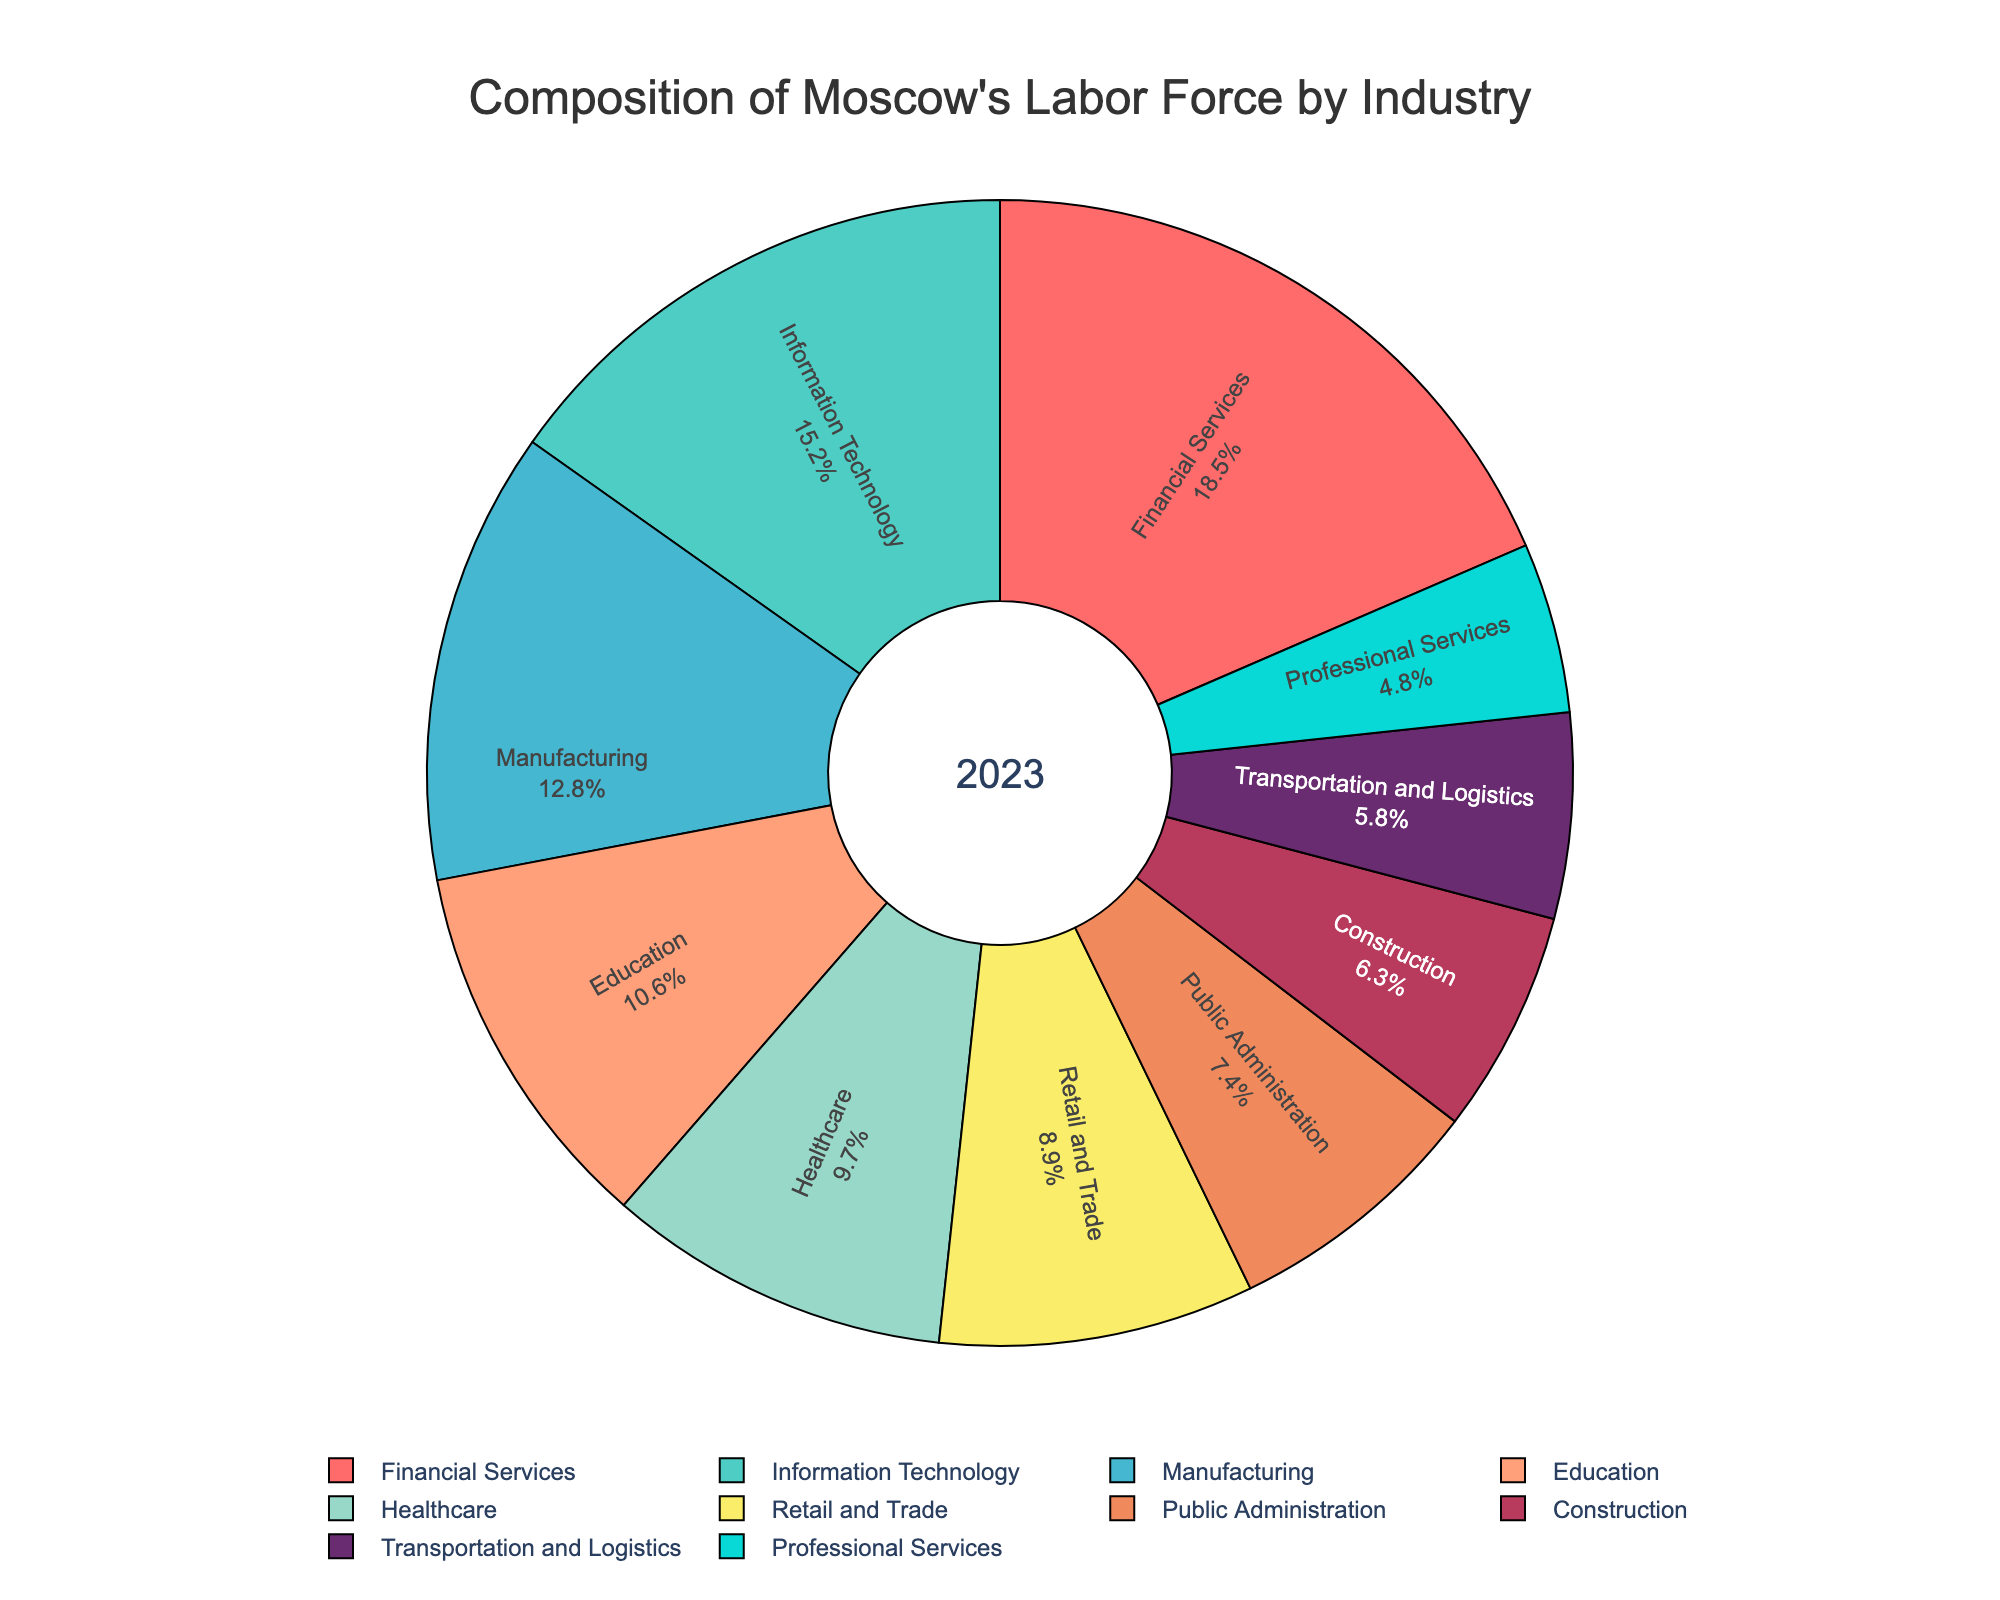Which industry has the largest percentage of Moscow's labor force? By examining the pie chart, Financial Services is the sector with the largest slice, corresponding to 18.5%.
Answer: Financial Services What is the combined percentage of Moscow's labor force in Information Technology, Manufacturing, and Education? Adding the percentages of these three industries: 15.2% (Information Technology) + 12.8% (Manufacturing) + 10.6% (Education) which sums up to 38.6%.
Answer: 38.6% Which industry has the smallest representation in Moscow's labor force? Public Administration has the smallest slice of the pie chart, corresponding to 4.8%.
Answer: Professional Services How does the percentage of Moscow's labor force in Retail and Trade compare to that in Healthcare? Retail and Trade accounts for 8.9% of the labor force, while Healthcare accounts for 9.7%. Hence, Healthcare has a higher percentage.
Answer: Healthcare has a higher percentage How many industries have a representation of more than 10% in Moscow's labor force? From the pie chart, the industries with more than 10% representation are Financial Services (18.5%), Information Technology (15.2%), Manufacturing (12.8%), and Education (10.6%). There are four such industries.
Answer: Four What's the difference in percentage between the labor force in Construction and Public Administration? Construction has 6.3% and Public Administration has 7.4%; the difference is 7.4% - 6.3% = 1.1%.
Answer: 1.1% What is the average percentage of Moscow's labor force in the three least represented industries? The three least represented industries are Public Administration (7.4%), Construction (6.3%), and Transportation and Logistics (5.8%). Their average is (7.4% + 6.3% + 5.8%) / 3 ≈ 6.5%.
Answer: 6.5% What color represents the Information Technology sector? Referring to the color mapping in the pie chart, Information Technology is represented by the cyan color.
Answer: Cyan What is the total percentage of labor force in sectors represented by shares smaller than 6%? The only sector with a percentage below 6% is Transportation and Logistics with 5.8%.
Answer: 5.8% Which sectors have a similar percentage of the labor force, and what are their percentages? Public Administration (7.4%) and Construction (6.3%) have similar percentages, with a difference of just 1.1%.
Answer: Public Administration and Construction 